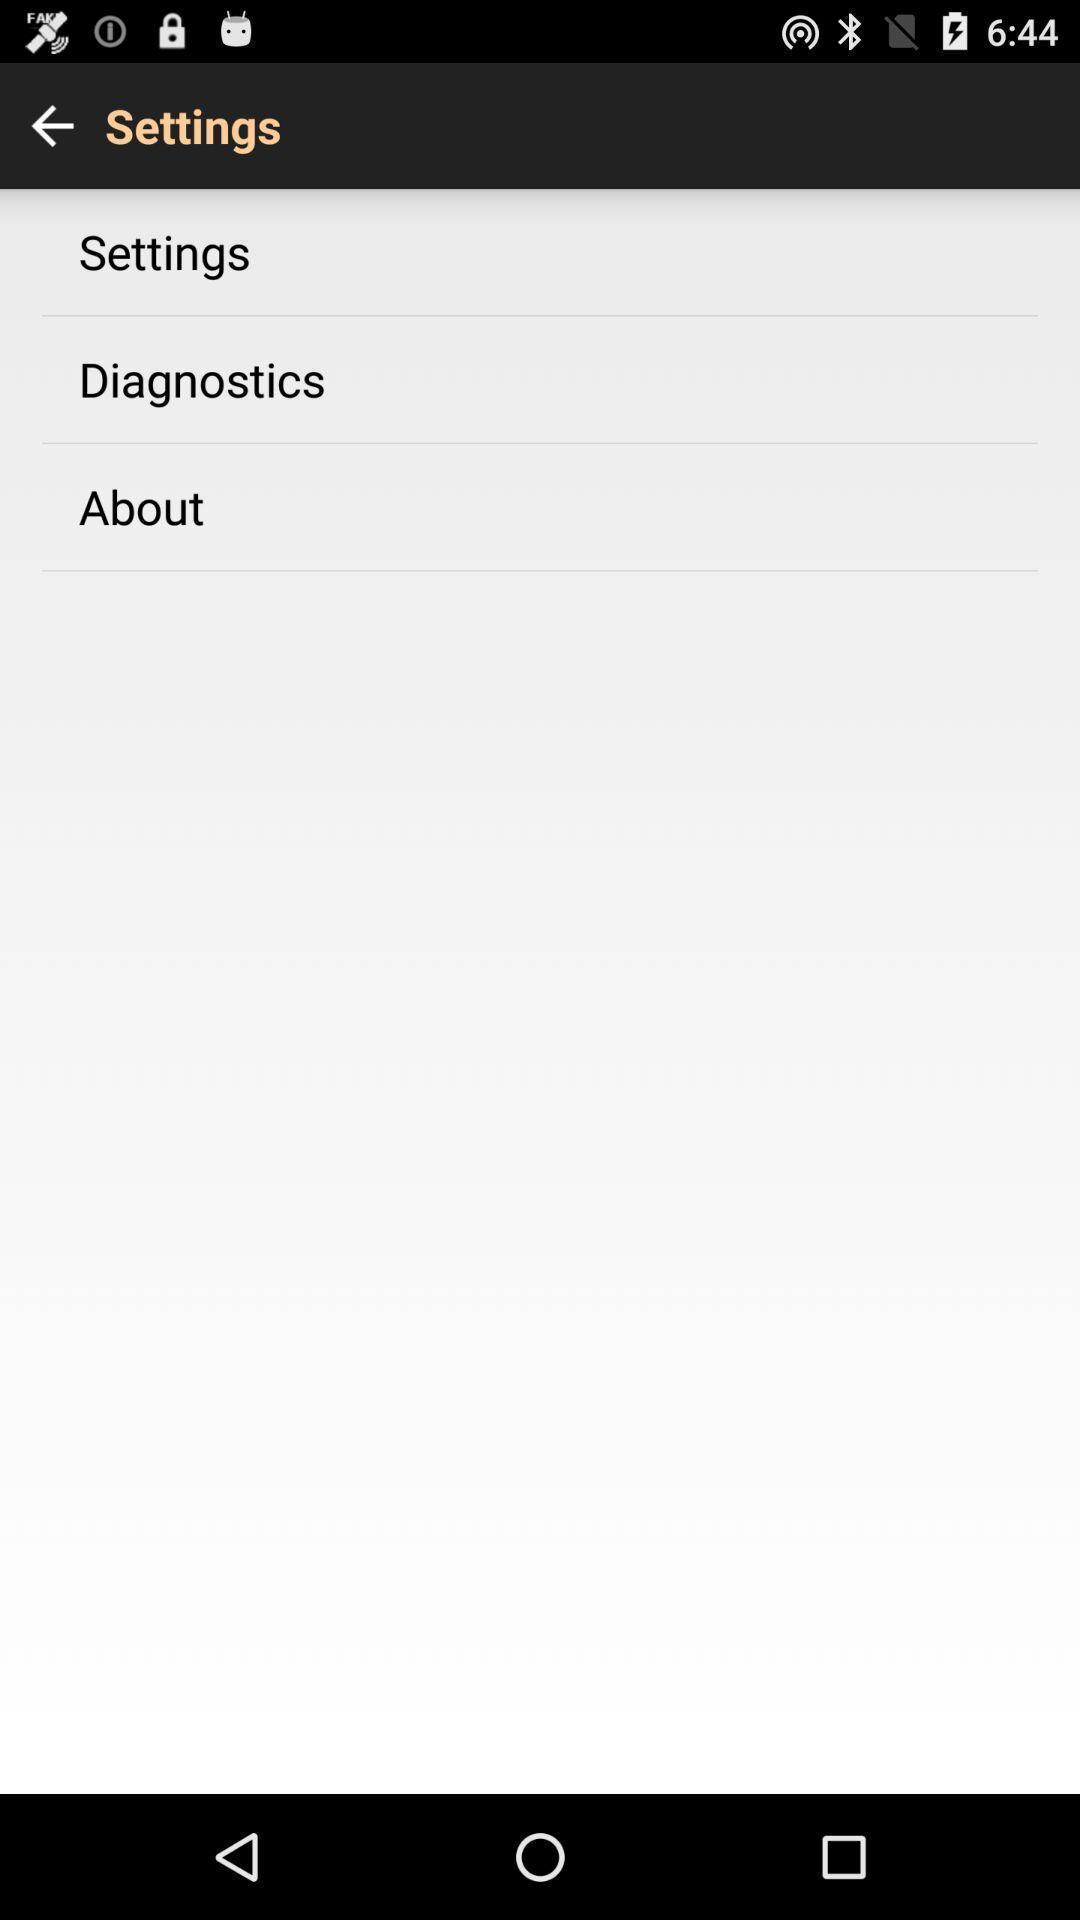Provide a textual representation of this image. Settings page. 